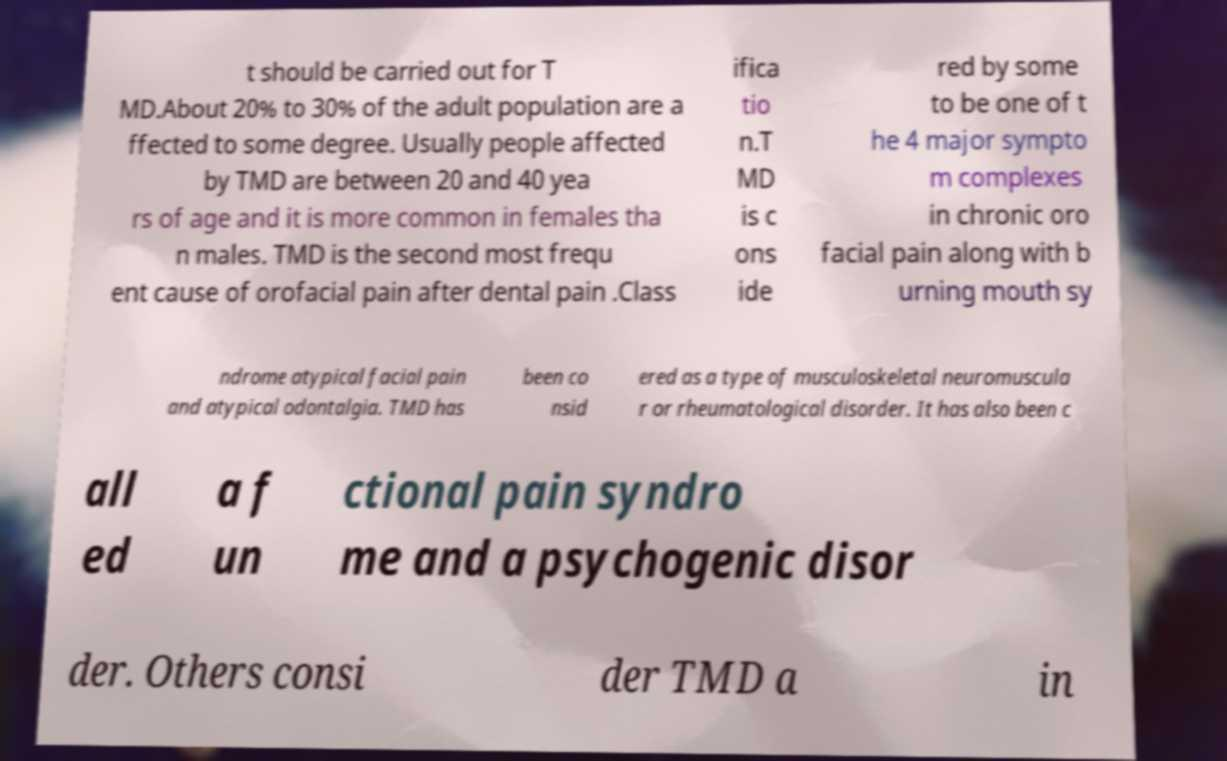Could you extract and type out the text from this image? t should be carried out for T MD.About 20% to 30% of the adult population are a ffected to some degree. Usually people affected by TMD are between 20 and 40 yea rs of age and it is more common in females tha n males. TMD is the second most frequ ent cause of orofacial pain after dental pain .Class ifica tio n.T MD is c ons ide red by some to be one of t he 4 major sympto m complexes in chronic oro facial pain along with b urning mouth sy ndrome atypical facial pain and atypical odontalgia. TMD has been co nsid ered as a type of musculoskeletal neuromuscula r or rheumatological disorder. It has also been c all ed a f un ctional pain syndro me and a psychogenic disor der. Others consi der TMD a in 